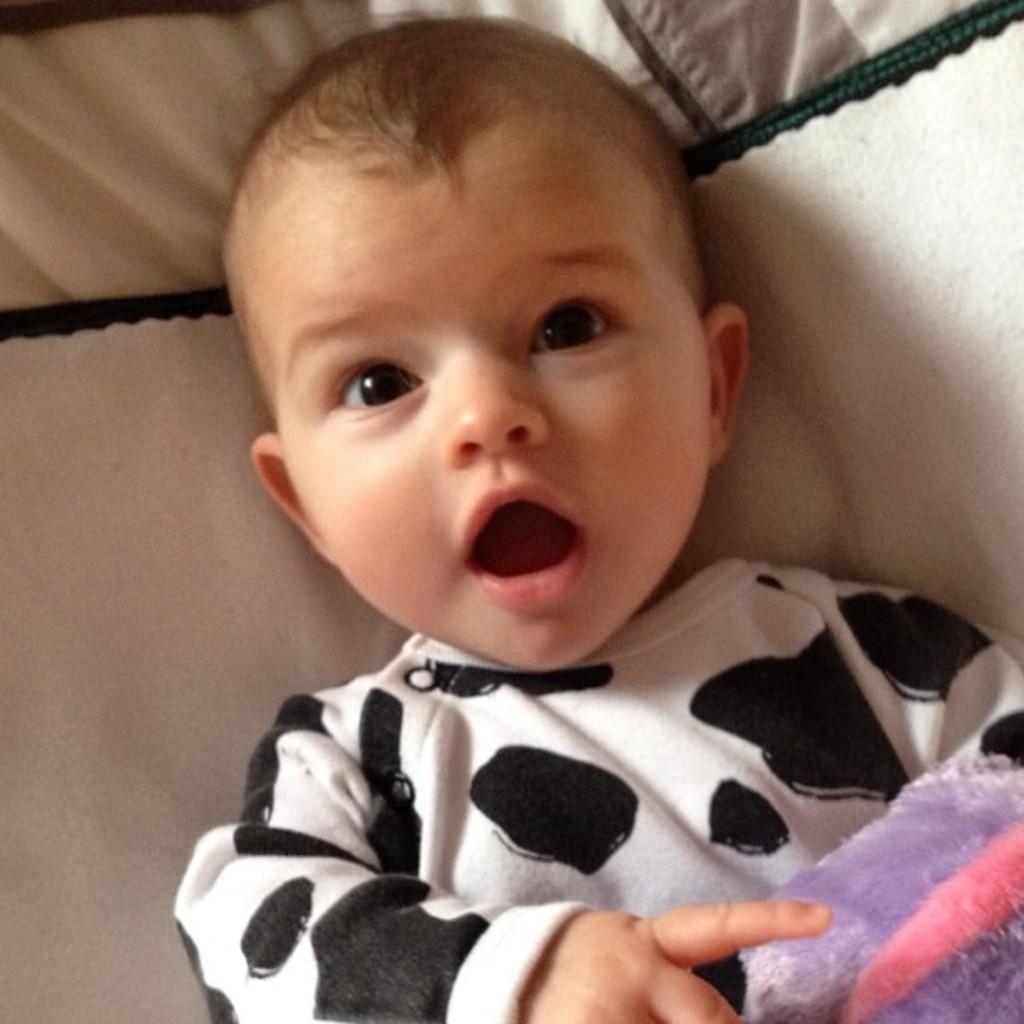Describe this image in one or two sentences. In this image I can see the baby lying on the cream color cloth and the baby is wearing black and white color dress. 